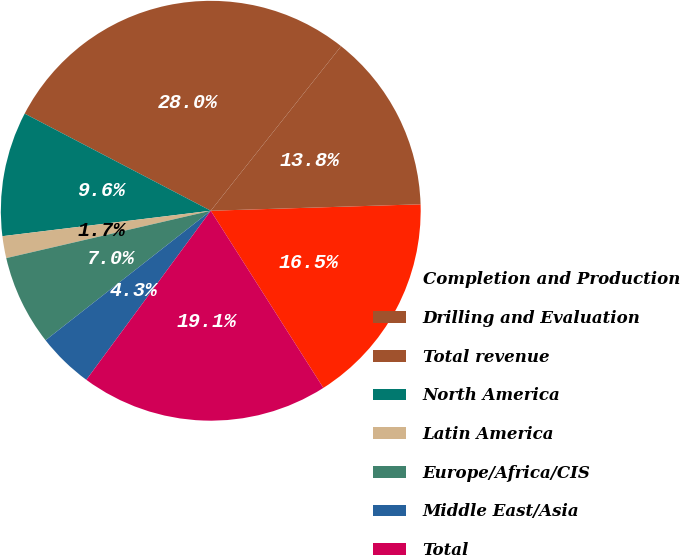<chart> <loc_0><loc_0><loc_500><loc_500><pie_chart><fcel>Completion and Production<fcel>Drilling and Evaluation<fcel>Total revenue<fcel>North America<fcel>Latin America<fcel>Europe/Africa/CIS<fcel>Middle East/Asia<fcel>Total<nl><fcel>16.48%<fcel>13.85%<fcel>28.01%<fcel>9.59%<fcel>1.69%<fcel>6.96%<fcel>4.32%<fcel>19.11%<nl></chart> 